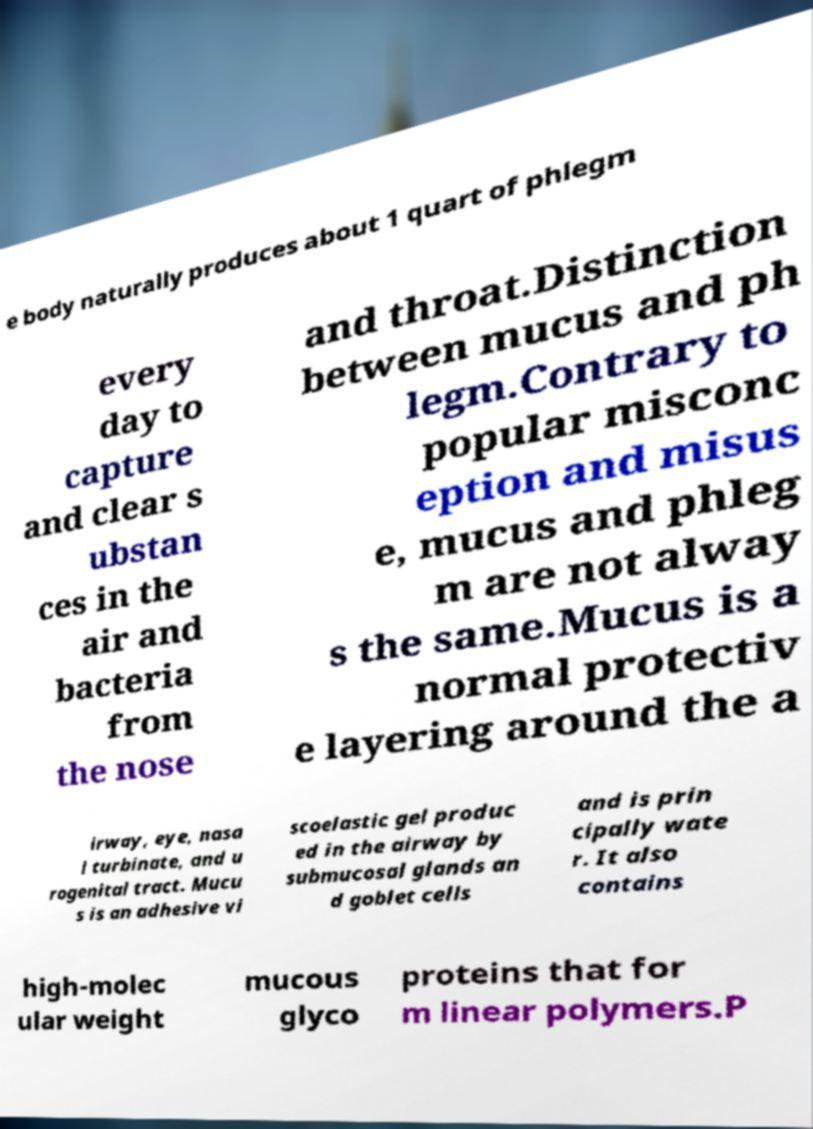I need the written content from this picture converted into text. Can you do that? e body naturally produces about 1 quart of phlegm every day to capture and clear s ubstan ces in the air and bacteria from the nose and throat.Distinction between mucus and ph legm.Contrary to popular misconc eption and misus e, mucus and phleg m are not alway s the same.Mucus is a normal protectiv e layering around the a irway, eye, nasa l turbinate, and u rogenital tract. Mucu s is an adhesive vi scoelastic gel produc ed in the airway by submucosal glands an d goblet cells and is prin cipally wate r. It also contains high-molec ular weight mucous glyco proteins that for m linear polymers.P 